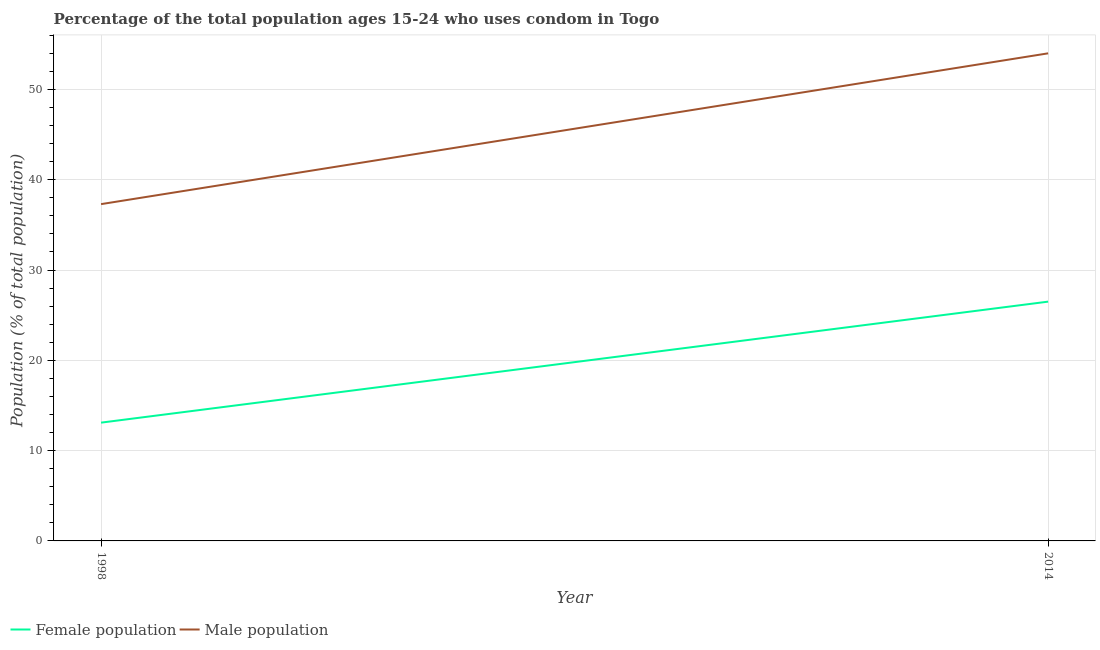Does the line corresponding to male population intersect with the line corresponding to female population?
Your answer should be compact. No. What is the female population in 2014?
Give a very brief answer. 26.5. Across all years, what is the maximum male population?
Your answer should be compact. 54. Across all years, what is the minimum male population?
Your response must be concise. 37.3. In which year was the female population minimum?
Make the answer very short. 1998. What is the total female population in the graph?
Make the answer very short. 39.6. What is the difference between the female population in 1998 and that in 2014?
Your response must be concise. -13.4. What is the difference between the female population in 1998 and the male population in 2014?
Your response must be concise. -40.9. What is the average male population per year?
Give a very brief answer. 45.65. In the year 2014, what is the difference between the female population and male population?
Your answer should be very brief. -27.5. What is the ratio of the male population in 1998 to that in 2014?
Your response must be concise. 0.69. Is the male population in 1998 less than that in 2014?
Keep it short and to the point. Yes. How many lines are there?
Ensure brevity in your answer.  2. What is the difference between two consecutive major ticks on the Y-axis?
Your answer should be very brief. 10. Are the values on the major ticks of Y-axis written in scientific E-notation?
Ensure brevity in your answer.  No. Does the graph contain grids?
Provide a succinct answer. Yes. How are the legend labels stacked?
Make the answer very short. Horizontal. What is the title of the graph?
Offer a very short reply. Percentage of the total population ages 15-24 who uses condom in Togo. Does "Depositors" appear as one of the legend labels in the graph?
Ensure brevity in your answer.  No. What is the label or title of the Y-axis?
Keep it short and to the point. Population (% of total population) . What is the Population (% of total population)  in Male population in 1998?
Your answer should be compact. 37.3. What is the Population (% of total population)  in Female population in 2014?
Provide a short and direct response. 26.5. Across all years, what is the maximum Population (% of total population)  in Male population?
Offer a terse response. 54. Across all years, what is the minimum Population (% of total population)  in Female population?
Ensure brevity in your answer.  13.1. Across all years, what is the minimum Population (% of total population)  of Male population?
Give a very brief answer. 37.3. What is the total Population (% of total population)  in Female population in the graph?
Your response must be concise. 39.6. What is the total Population (% of total population)  of Male population in the graph?
Your response must be concise. 91.3. What is the difference between the Population (% of total population)  in Male population in 1998 and that in 2014?
Keep it short and to the point. -16.7. What is the difference between the Population (% of total population)  in Female population in 1998 and the Population (% of total population)  in Male population in 2014?
Ensure brevity in your answer.  -40.9. What is the average Population (% of total population)  of Female population per year?
Offer a very short reply. 19.8. What is the average Population (% of total population)  of Male population per year?
Keep it short and to the point. 45.65. In the year 1998, what is the difference between the Population (% of total population)  in Female population and Population (% of total population)  in Male population?
Ensure brevity in your answer.  -24.2. In the year 2014, what is the difference between the Population (% of total population)  of Female population and Population (% of total population)  of Male population?
Make the answer very short. -27.5. What is the ratio of the Population (% of total population)  of Female population in 1998 to that in 2014?
Ensure brevity in your answer.  0.49. What is the ratio of the Population (% of total population)  in Male population in 1998 to that in 2014?
Offer a very short reply. 0.69. What is the difference between the highest and the second highest Population (% of total population)  in Male population?
Your response must be concise. 16.7. What is the difference between the highest and the lowest Population (% of total population)  of Female population?
Provide a succinct answer. 13.4. What is the difference between the highest and the lowest Population (% of total population)  of Male population?
Ensure brevity in your answer.  16.7. 